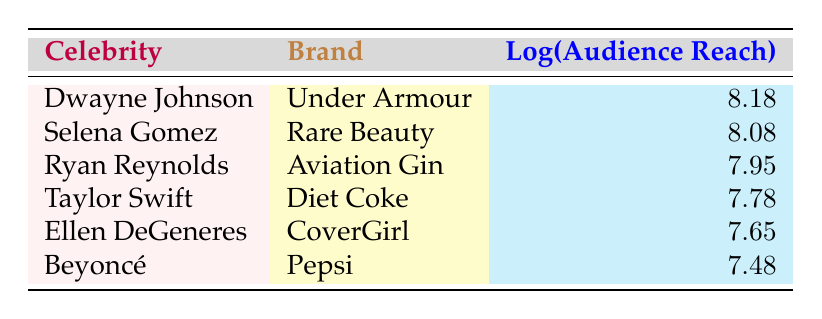What is the audience reach of Dwayne Johnson's advertisement for Under Armour? According to the table, Dwayne Johnson's advertisement for Under Armour has an audience reach of 150,000,000.
Answer: 150,000,000 Who has a higher audience reach, Selena Gomez or Ryan Reynolds? The audience reach for Selena Gomez (120,000,000) is higher than that of Ryan Reynolds (90,000,000). Therefore, Selena Gomez has a higher reach.
Answer: Selena Gomez What is the combined audience reach of the commercials featuring Ellen DeGeneres and Beyoncé? Ellen DeGeneres has an audience reach of 45,000,000, and Beyoncé has an audience reach of 30,000,000. Their combined reach is 45,000,000 + 30,000,000 = 75,000,000.
Answer: 75,000,000 Is the audience reach of Taylor Swift's advertisement greater than 100,000,000? Taylor Swift's advertisement for Diet Coke has an audience reach of 60,000,000, which is less than 100,000,000. Therefore, the statement is false.
Answer: No What is the average audience reach of the commercials listed in the table? To find the average, first sum the audience reaches: 150,000,000 + 120,000,000 + 90,000,000 + 60,000,000 + 45,000,000 + 30,000,000 = 495,000,000. There are 6 commercials, so the average is 495,000,000 / 6 = 82,500,000.
Answer: 82,500,000 Which brand has the lowest audience reach and what is that reach? The brand with the lowest audience reach is Pepsi, endorsed by Beyoncé, with an audience reach of 30,000,000.
Answer: Pepsi, 30,000,000 How many celebrities have an audience reach of more than 80,000,000? Dwayne Johnson (150,000,000), Selena Gomez (120,000,000), and Ryan Reynolds (90,000,000) all have an audience reach above 80,000,000. Therefore, there are 3 celebrities.
Answer: 3 Is the audience reach of Ellen DeGeneres more than half of Dwayne Johnson's audience reach? Dwayne Johnson's reach is 150,000,000. Half of that is 75,000,000. Ellen DeGeneres' reach is 45,000,000, which is less than 75,000,000. Therefore, the statement is false.
Answer: No 